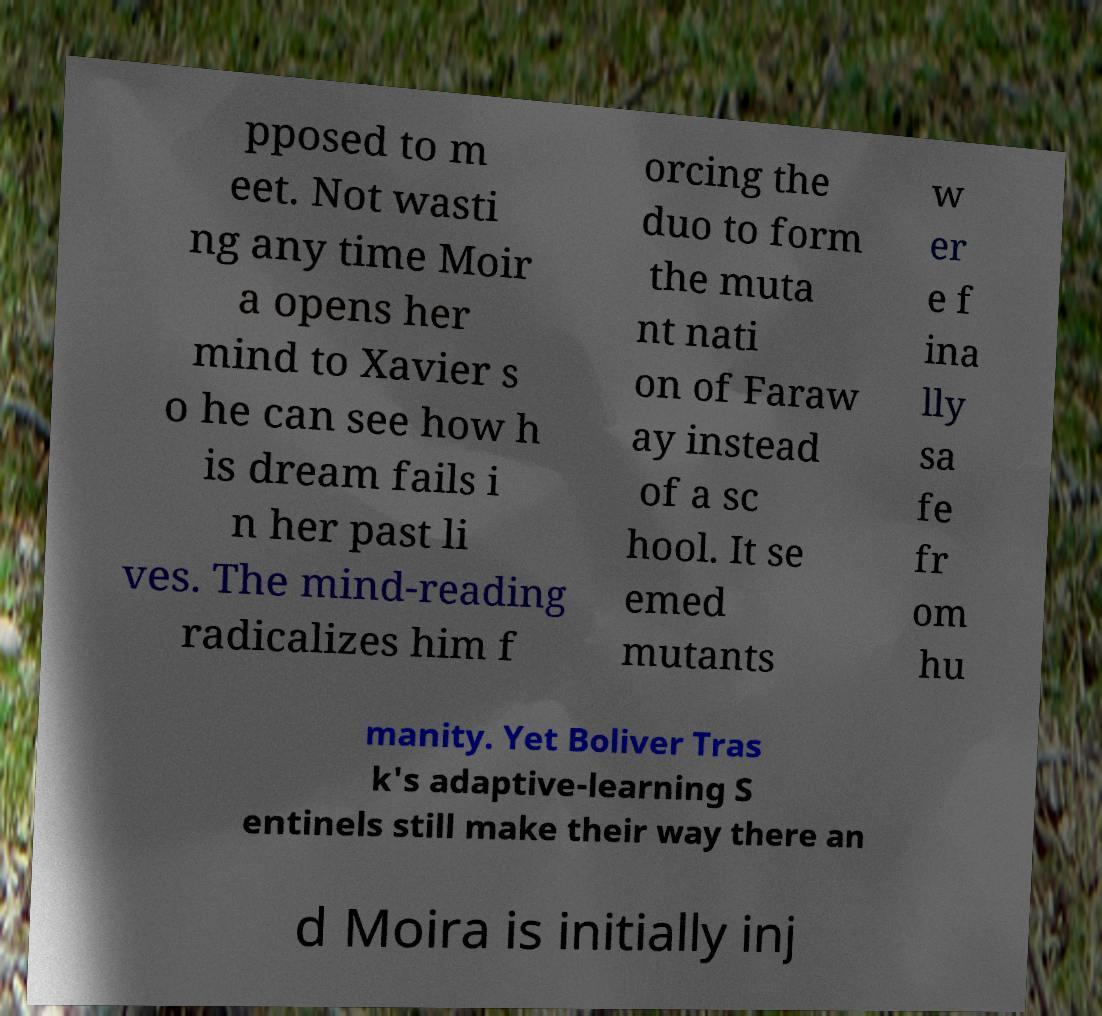Please read and relay the text visible in this image. What does it say? pposed to m eet. Not wasti ng any time Moir a opens her mind to Xavier s o he can see how h is dream fails i n her past li ves. The mind-reading radicalizes him f orcing the duo to form the muta nt nati on of Faraw ay instead of a sc hool. It se emed mutants w er e f ina lly sa fe fr om hu manity. Yet Boliver Tras k's adaptive-learning S entinels still make their way there an d Moira is initially inj 